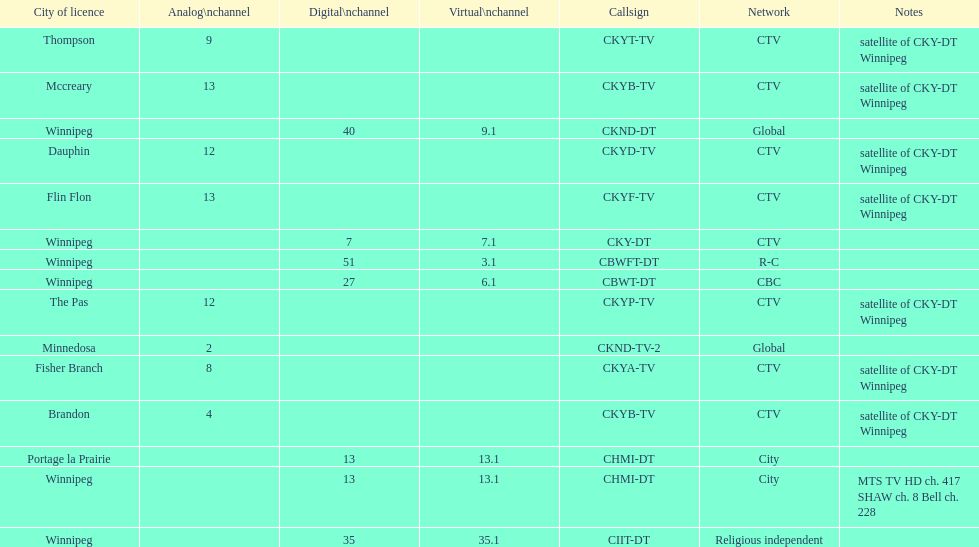Which network has the most satellite stations? CTV. 